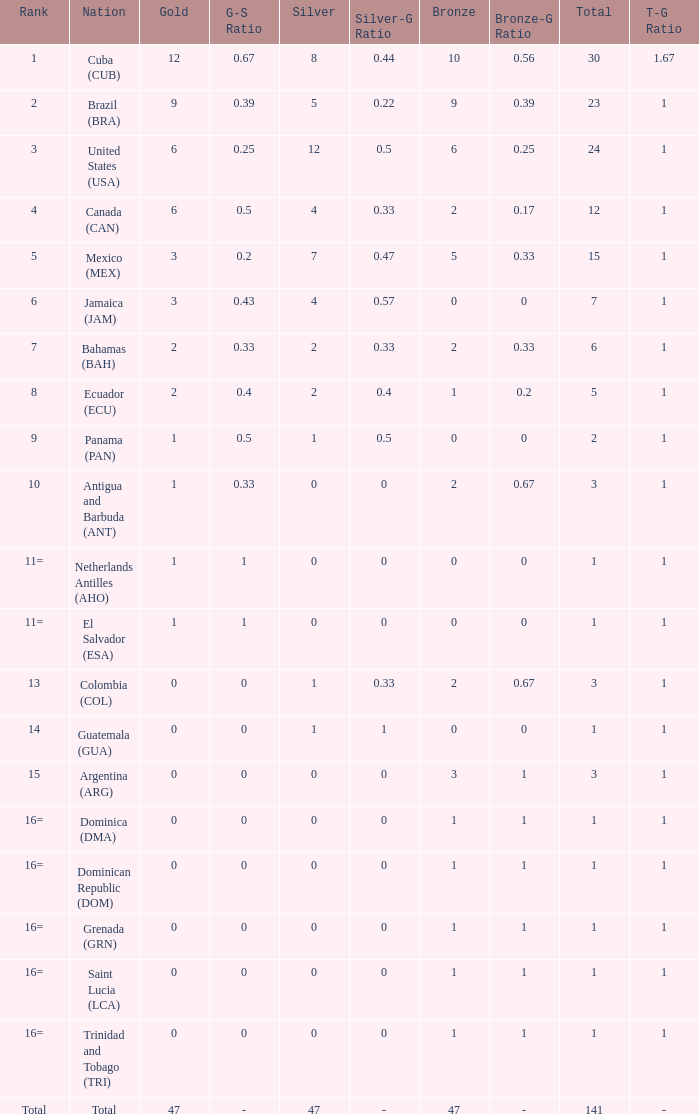What is the average silver with more than 0 gold, a Rank of 1, and a Total smaller than 30? None. Could you help me parse every detail presented in this table? {'header': ['Rank', 'Nation', 'Gold', 'G-S Ratio', 'Silver', 'Silver-G Ratio', 'Bronze', 'Bronze-G Ratio', 'Total', 'T-G Ratio'], 'rows': [['1', 'Cuba (CUB)', '12', '0.67', '8', '0.44', '10', '0.56', '30', '1.67'], ['2', 'Brazil (BRA)', '9', '0.39', '5', '0.22', '9', '0.39', '23', '1'], ['3', 'United States (USA)', '6', '0.25', '12', '0.5', '6', '0.25', '24', '1'], ['4', 'Canada (CAN)', '6', '0.5', '4', '0.33', '2', '0.17', '12', '1'], ['5', 'Mexico (MEX)', '3', '0.2', '7', '0.47', '5', '0.33', '15', '1'], ['6', 'Jamaica (JAM)', '3', '0.43', '4', '0.57', '0', '0', '7', '1'], ['7', 'Bahamas (BAH)', '2', '0.33', '2', '0.33', '2', '0.33', '6', '1'], ['8', 'Ecuador (ECU)', '2', '0.4', '2', '0.4', '1', '0.2', '5', '1'], ['9', 'Panama (PAN)', '1', '0.5', '1', '0.5', '0', '0', '2', '1'], ['10', 'Antigua and Barbuda (ANT)', '1', '0.33', '0', '0', '2', '0.67', '3', '1'], ['11=', 'Netherlands Antilles (AHO)', '1', '1', '0', '0', '0', '0', '1', '1'], ['11=', 'El Salvador (ESA)', '1', '1', '0', '0', '0', '0', '1', '1'], ['13', 'Colombia (COL)', '0', '0', '1', '0.33', '2', '0.67', '3', '1'], ['14', 'Guatemala (GUA)', '0', '0', '1', '1', '0', '0', '1', '1'], ['15', 'Argentina (ARG)', '0', '0', '0', '0', '3', '1', '3', '1'], ['16=', 'Dominica (DMA)', '0', '0', '0', '0', '1', '1', '1', '1'], ['16=', 'Dominican Republic (DOM)', '0', '0', '0', '0', '1', '1', '1', '1'], ['16=', 'Grenada (GRN)', '0', '0', '0', '0', '1', '1', '1', '1'], ['16=', 'Saint Lucia (LCA)', '0', '0', '0', '0', '1', '1', '1', '1'], ['16=', 'Trinidad and Tobago (TRI)', '0', '0', '0', '0', '1', '1', '1', '1'], ['Total', 'Total', '47', '-', '47', '-', '47', '-', '141', '-']]} 